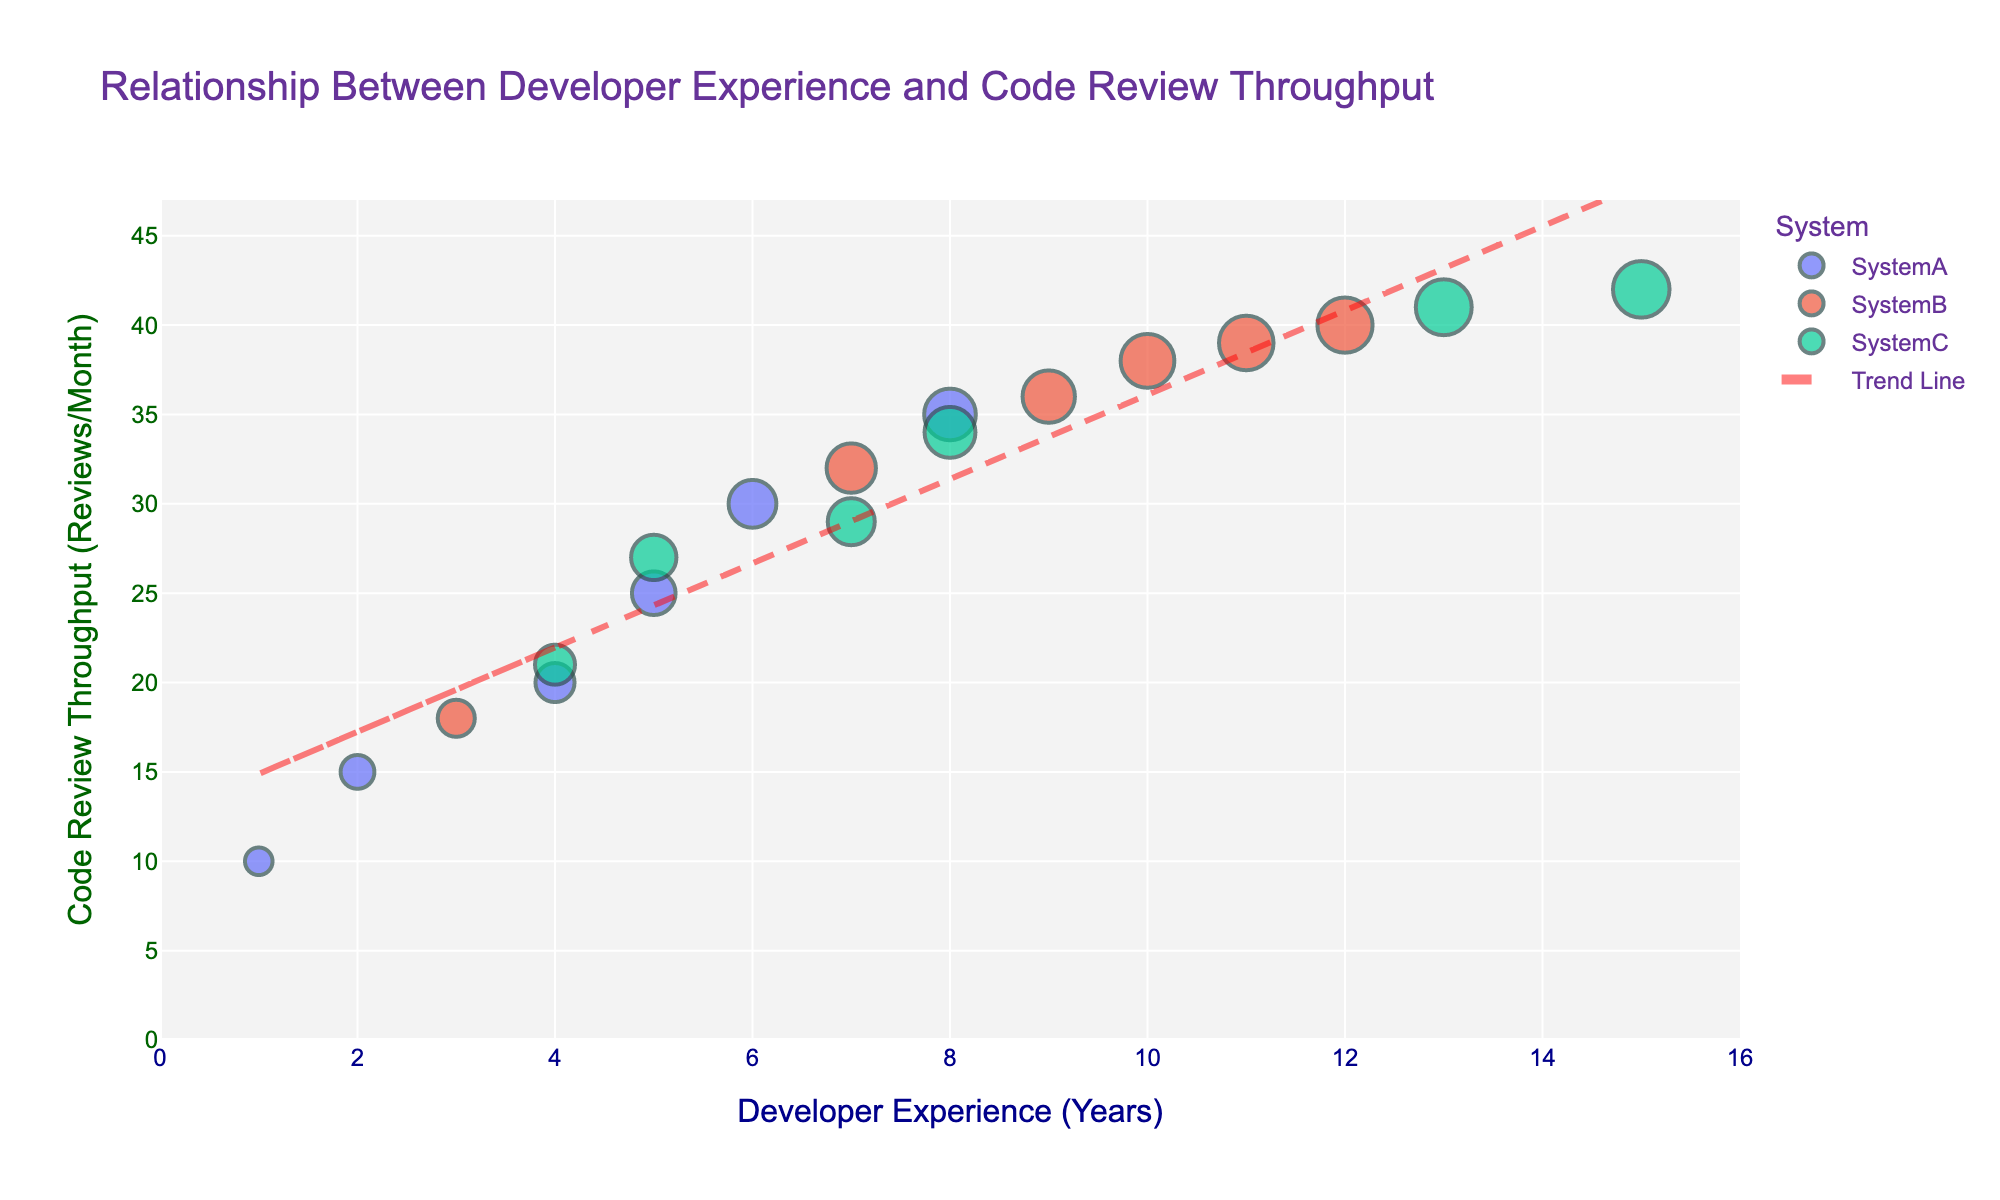What is the title of the plot? The title of the plot is displayed at the top and describes the content of the figure.
Answer: Relationship Between Developer Experience and Code Review Throughput How many teams are represented in the plot? There are different colors representing different teams. Each unique color in the legend corresponds to a separate team.
Answer: 3 In which team does the developer with 12 years of experience belong? Each data point on the plot represents a developer, and the legend indicates the team. The point for 12 years of experience matches the color assigned to Team SystemB.
Answer: SystemB What is the trend observed in the relationship between Developer Experience and Code Review Throughput? The trend line shows the overall direction of the data as a whole. Observing the trend line indicates whether the throughput increases or decreases with experience.
Answer: Code Review Throughput increases with Developer Experience Which developer, regardless of team, has the highest Code Review Throughput? By looking at the y-axis, identifying the highest value, and referencing its corresponding point on the plot indicates the maximum throughput observed.
Answer: Developer in SystemC with 15 years of experience (42 reviews per month) Which team has the most developers with over 10 years of experience? Looking at the x-axis for values greater than 10 and counting the number of corresponding data points in each team based on their colors.
Answer: SystemB What is the approximate Code Review Throughput for a developer with 7 years of experience in SystemB? Locate the data point where the x-value is 7 and the color matches SystemB, then read off the y-value.
Answer: 32 reviews per month Which team shows the highest variability in Code Review Throughput for developers with less than 10 years of experience? By looking at the spread of data points and range of values on the y-axis for each team, we can measure the variability.
Answer: SystemA 